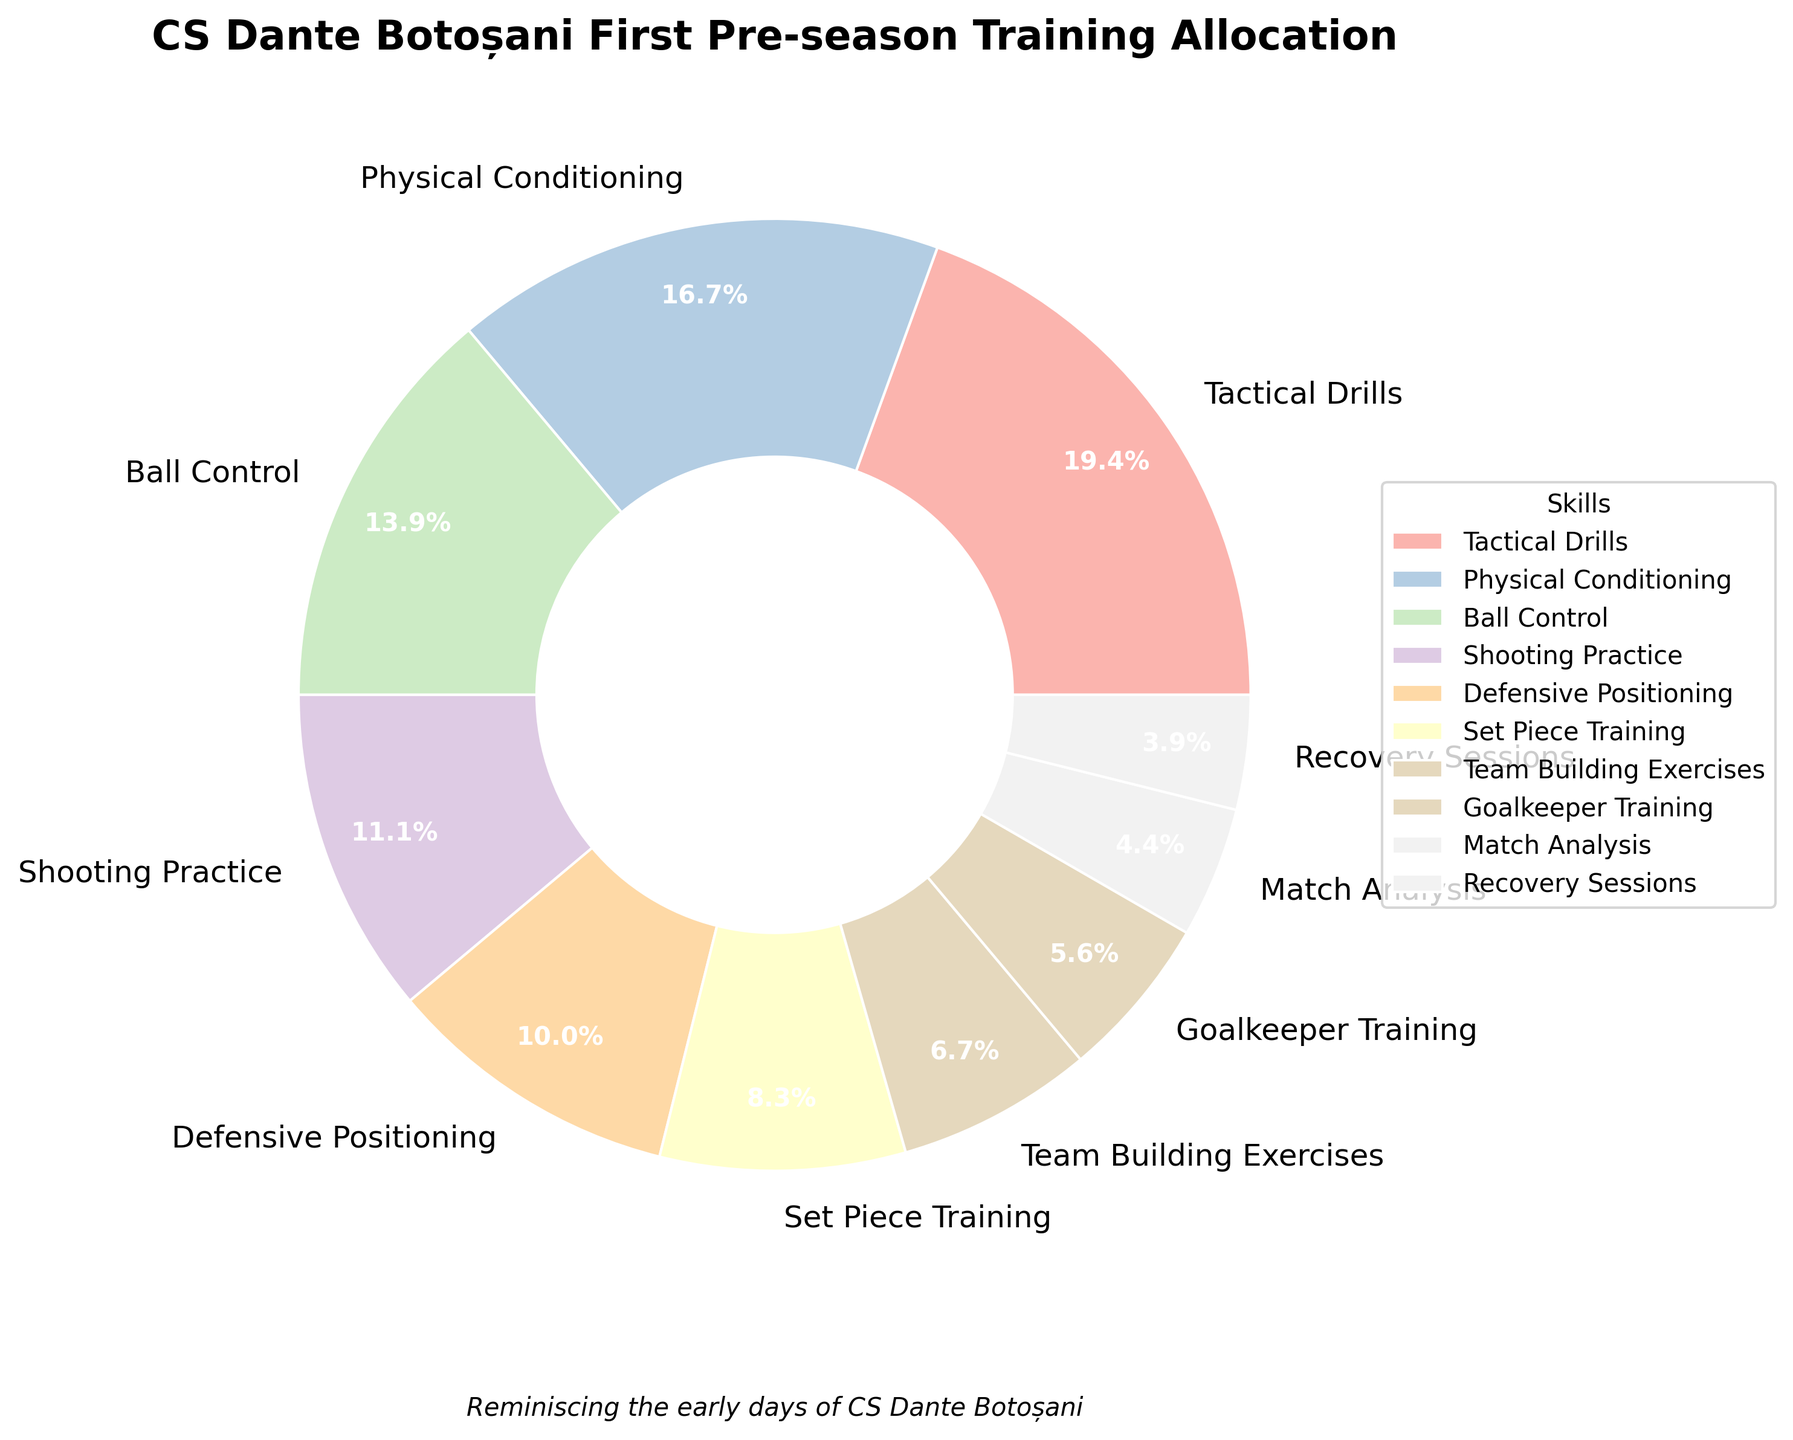Which skill received the most training hours? Look at the segments in the pie chart and identify the one with the largest slice. This corresponds to the skill with the most training hours.
Answer: Tactical Drills Which skill has the smallest allocation of training time? Identify the smallest slice in the pie chart, which indicates the skill with the least training hours.
Answer: Recovery Sessions What is the combined percentage of training time for Ball Control and Shooting Practice? Identify the individual percentages for Ball Control and Shooting Practice from the pie chart, then add them together. Ball Control is 16.3% and Shooting Practice is 13%. Therefore, their combined percentage is 16.3% + 13% = 29.3%.
Answer: 29.3% Is the amount of time allocated for Goalkeeper Training greater than Recovery Sessions? Compare the sizes of the slices for Goalkeeper Training and Recovery Sessions. Goalkeeper Training has a larger slice compared to Recovery Sessions.
Answer: Yes How many hours more were spent on Physical Conditioning than Recovery Sessions? Find the difference between the hours allocated to Physical Conditioning (30 hours) and Recovery Sessions (7 hours). Calculate 30 - 7 = 23 hours.
Answer: 23 hours What percentage of the training time focused on Tactical Drills and Physical Conditioning combined? Sum the hours for Tactical Drills and Physical Conditioning (35 + 30 = 65 hours). Then, calculate the percentage: (65 / total hours) * 100. The total hours are the sum of all hours (35 + 30 + 25 + 20 + 18 + 15 + 12 + 10 + 8 + 7 = 180 hours). So, (65 / 180) * 100 ≈ 36.1%.
Answer: 36.1% What is the average number of hours spent on Training Skills that have over 10% time allocation? Identify the skills with over 10% time allocation: Tactical Drills (19.4%), Physical Conditioning (16.7%), and Ball Control (13.9%). Calculate the average of their hours: (35 + 30 + 25) / 3.
Answer: 30 hours Which skill received exactly one-fourth of Tactical Drills' training hours? Determine one-fourth of Tactical Drills' hours (35 hours): 35 / 4 = 8.75 hours. Match this to the closest skill, which is Match Analysis (8 hours).
Answer: Match Analysis How does the training time for Team Building Exercises compare to Set Piece Training? Compare the slices for Team Building Exercises and Set Piece Training. Team Building Exercises is allocated less time (12 hours) compared to Set Piece Training (15 hours).
Answer: Less What is the difference in percentage points between the training time for Defensive Positioning and Set Piece Training? Identify the percentages for Defensive Positioning and Set Piece Training from the pie chart. Defensive Positioning is 10%, and Set Piece Training is 8.3%. Calculate the difference: 10% - 8.3% = 1.7%.
Answer: 1.7% 